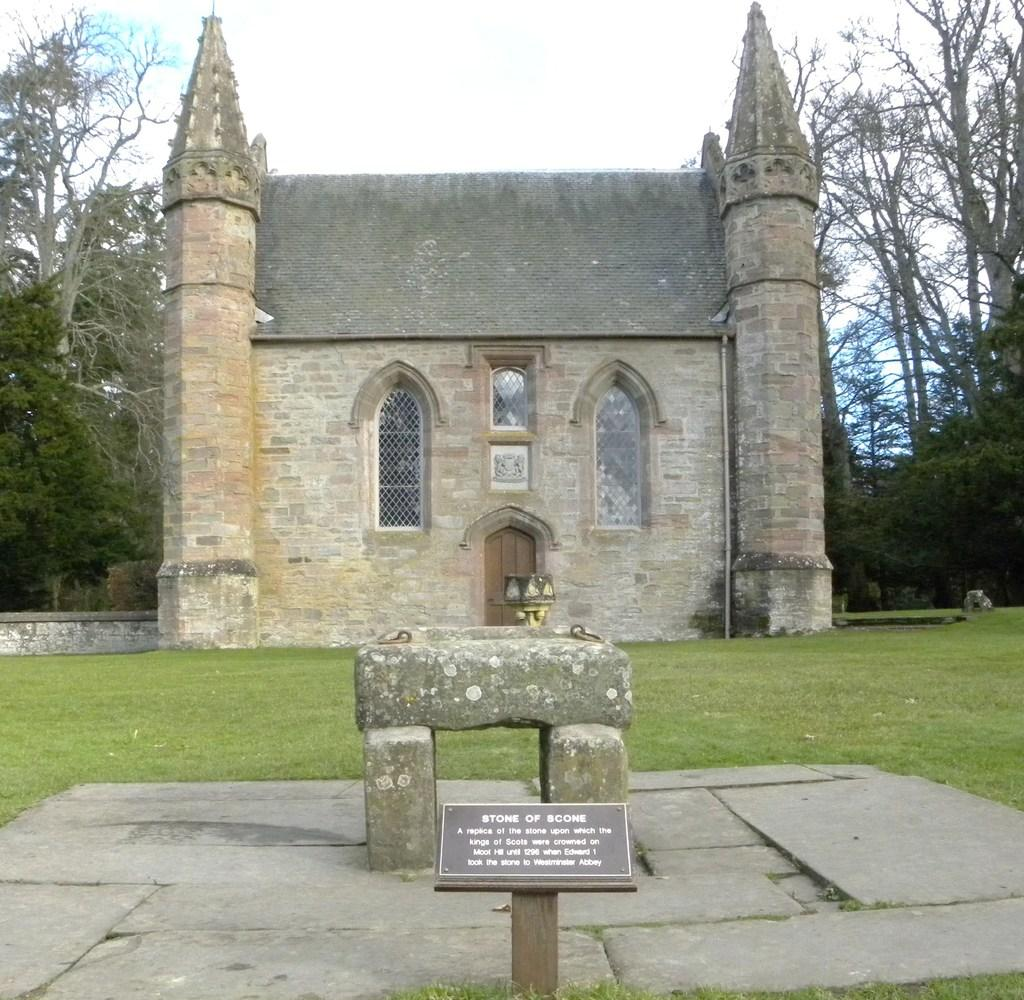What is the main structure in the image? There is a building in the image. What is located in front of the building? There is a notice board in front of the building. What can be seen in the distance behind the building? Trees are visible in the background of the image. What type of fruit is hanging from the branch in the image? There is no fruit or branch present in the image. 